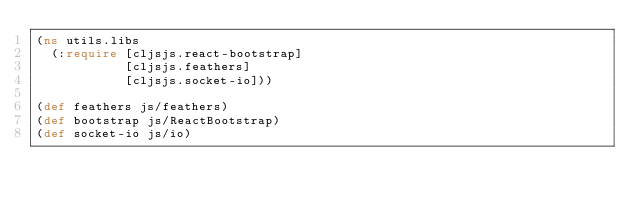Convert code to text. <code><loc_0><loc_0><loc_500><loc_500><_Clojure_>(ns utils.libs
  (:require [cljsjs.react-bootstrap]
            [cljsjs.feathers]
            [cljsjs.socket-io]))

(def feathers js/feathers)
(def bootstrap js/ReactBootstrap)
(def socket-io js/io)

</code> 